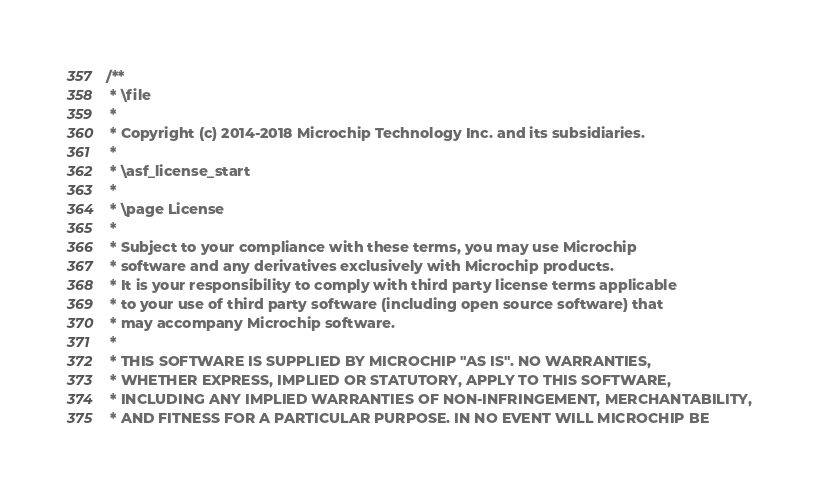<code> <loc_0><loc_0><loc_500><loc_500><_C_>/**
 * \file
 *
 * Copyright (c) 2014-2018 Microchip Technology Inc. and its subsidiaries.
 *
 * \asf_license_start
 *
 * \page License
 *
 * Subject to your compliance with these terms, you may use Microchip
 * software and any derivatives exclusively with Microchip products.
 * It is your responsibility to comply with third party license terms applicable
 * to your use of third party software (including open source software) that
 * may accompany Microchip software.
 *
 * THIS SOFTWARE IS SUPPLIED BY MICROCHIP "AS IS". NO WARRANTIES,
 * WHETHER EXPRESS, IMPLIED OR STATUTORY, APPLY TO THIS SOFTWARE,
 * INCLUDING ANY IMPLIED WARRANTIES OF NON-INFRINGEMENT, MERCHANTABILITY,
 * AND FITNESS FOR A PARTICULAR PURPOSE. IN NO EVENT WILL MICROCHIP BE</code> 